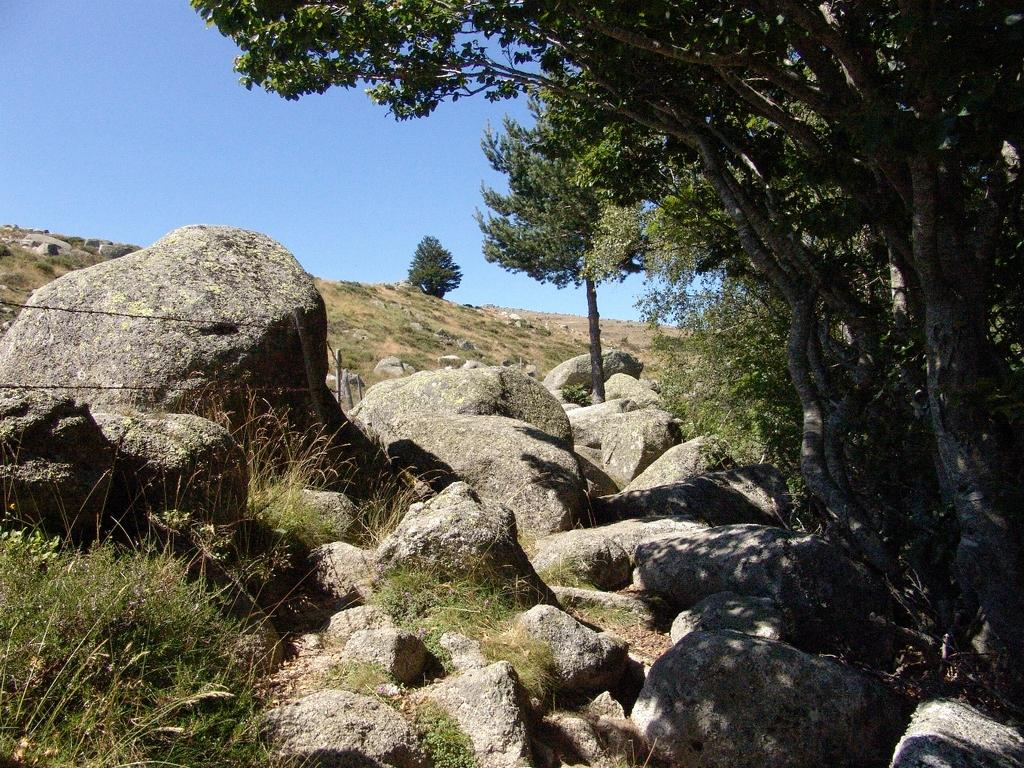What type of vegetation is on the right side of the image? There are trees on the right side of the image. What is present at the bottom of the image? There is grass and rocks at the bottom of the image. What is visible at the top of the image? The sky is visible at the top of the image. What type of lead can be seen in the image? There is no lead present in the image. What type of patch is visible on the trees in the image? There are no patches visible on the trees in the image. 